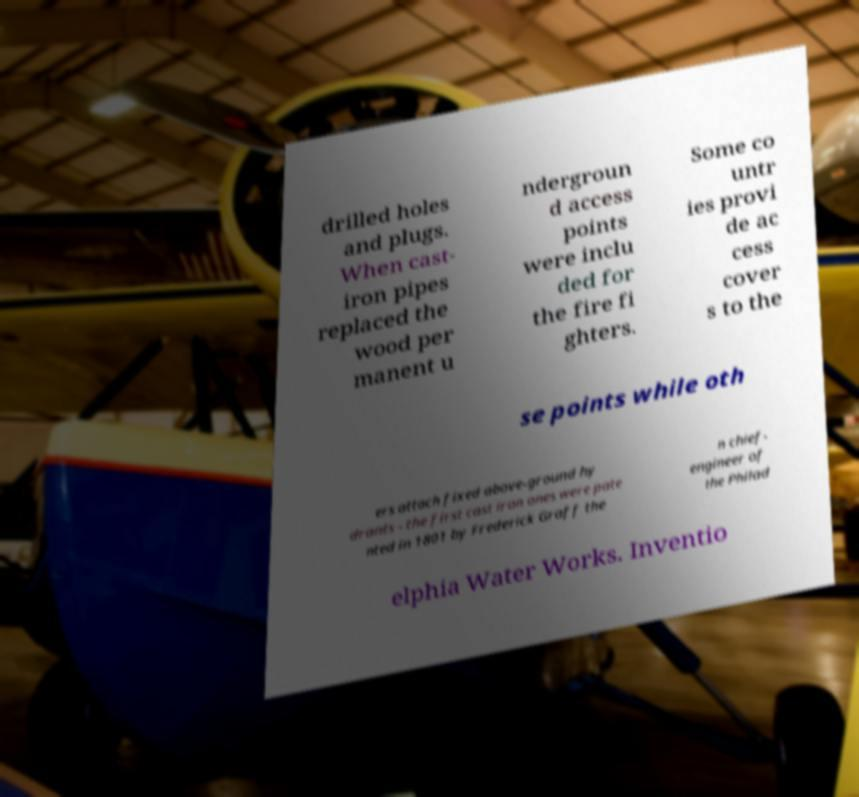Could you assist in decoding the text presented in this image and type it out clearly? drilled holes and plugs. When cast- iron pipes replaced the wood per manent u ndergroun d access points were inclu ded for the fire fi ghters. Some co untr ies provi de ac cess cover s to the se points while oth ers attach fixed above-ground hy drants - the first cast iron ones were pate nted in 1801 by Frederick Graff the n chief- engineer of the Philad elphia Water Works. Inventio 